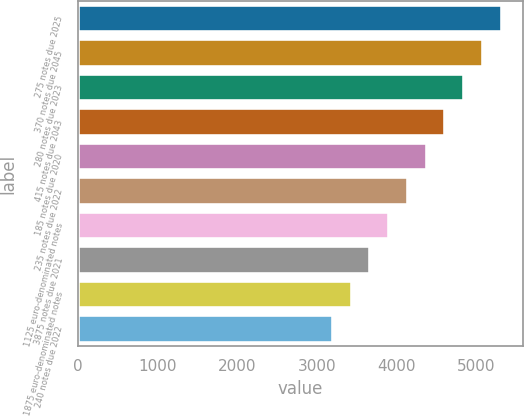Convert chart. <chart><loc_0><loc_0><loc_500><loc_500><bar_chart><fcel>275 notes due 2025<fcel>370 notes due 2045<fcel>280 notes due 2023<fcel>415 notes due 2043<fcel>185 notes due 2020<fcel>235 notes due 2022<fcel>1125 euro-denominated notes<fcel>3875 notes due 2021<fcel>1875 euro-denominated notes<fcel>240 notes due 2022<nl><fcel>5316<fcel>5080.5<fcel>4845<fcel>4609.5<fcel>4374<fcel>4138.5<fcel>3903<fcel>3667.5<fcel>3432<fcel>3196.5<nl></chart> 